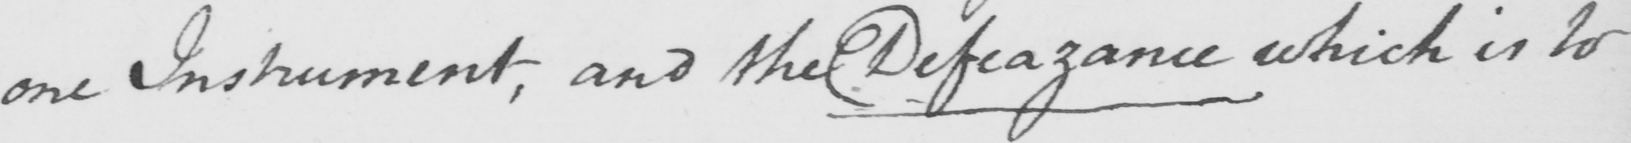Transcribe the text shown in this historical manuscript line. one Instrument , and the Defeazance which is to 